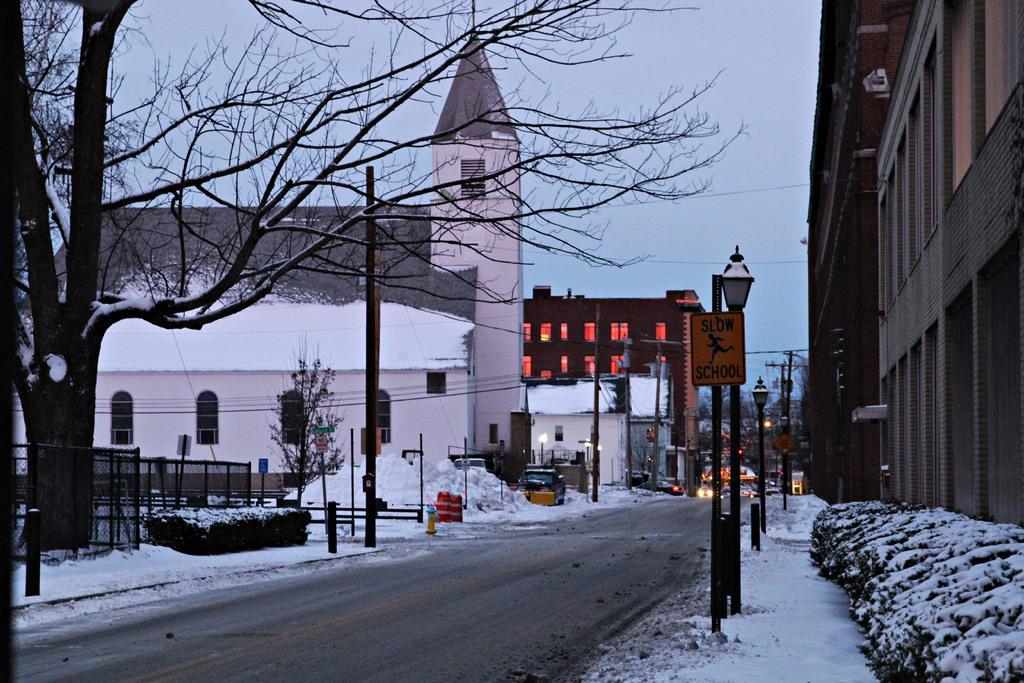In one or two sentences, can you explain what this image depicts? In this image we can see the road, shrubs covered with snow, caution boards, light poles, trees, buildings, cars parked here, vehicles moving on the road and the sky in the background. 